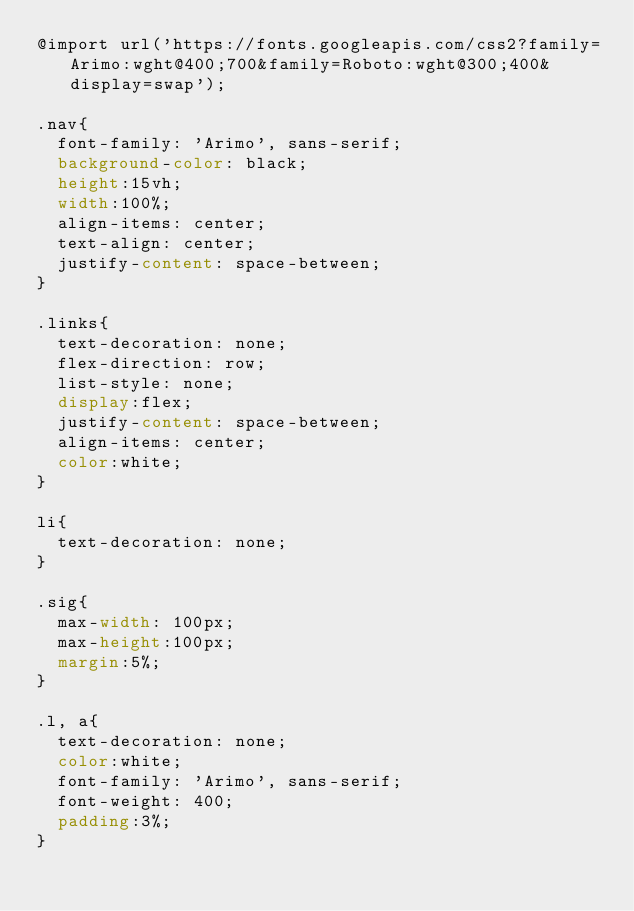<code> <loc_0><loc_0><loc_500><loc_500><_CSS_>@import url('https://fonts.googleapis.com/css2?family=Arimo:wght@400;700&family=Roboto:wght@300;400&display=swap');

.nav{
  font-family: 'Arimo', sans-serif;
  background-color: black;
  height:15vh;
  width:100%;
  align-items: center;
  text-align: center;
  justify-content: space-between;
}

.links{
  text-decoration: none;
  flex-direction: row;
  list-style: none;
  display:flex;
  justify-content: space-between;
  align-items: center;
  color:white;
}

li{
  text-decoration: none;
}

.sig{
  max-width: 100px;
  max-height:100px;
  margin:5%;
}

.l, a{
  text-decoration: none;
  color:white;
  font-family: 'Arimo', sans-serif;
  font-weight: 400;
  padding:3%;
}</code> 